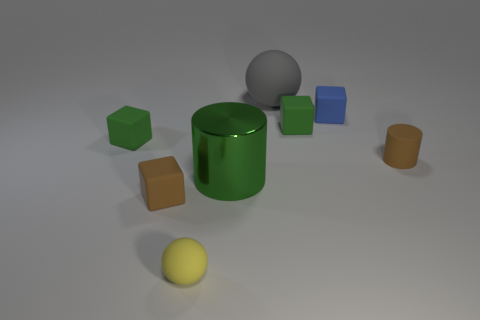Add 2 tiny balls. How many objects exist? 10 Subtract all balls. How many objects are left? 6 Add 5 tiny blue matte blocks. How many tiny blue matte blocks exist? 6 Subtract 0 purple spheres. How many objects are left? 8 Subtract all shiny objects. Subtract all big green matte things. How many objects are left? 7 Add 1 yellow objects. How many yellow objects are left? 2 